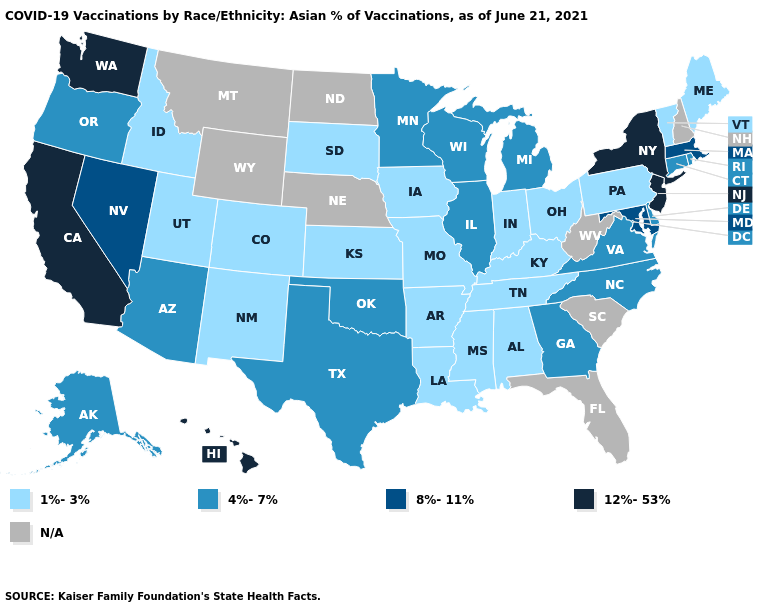Name the states that have a value in the range 4%-7%?
Answer briefly. Alaska, Arizona, Connecticut, Delaware, Georgia, Illinois, Michigan, Minnesota, North Carolina, Oklahoma, Oregon, Rhode Island, Texas, Virginia, Wisconsin. Name the states that have a value in the range 8%-11%?
Give a very brief answer. Maryland, Massachusetts, Nevada. Does Maine have the lowest value in the Northeast?
Quick response, please. Yes. What is the highest value in the Northeast ?
Concise answer only. 12%-53%. What is the lowest value in the West?
Answer briefly. 1%-3%. Name the states that have a value in the range 1%-3%?
Concise answer only. Alabama, Arkansas, Colorado, Idaho, Indiana, Iowa, Kansas, Kentucky, Louisiana, Maine, Mississippi, Missouri, New Mexico, Ohio, Pennsylvania, South Dakota, Tennessee, Utah, Vermont. What is the value of Alabama?
Short answer required. 1%-3%. Which states have the lowest value in the MidWest?
Short answer required. Indiana, Iowa, Kansas, Missouri, Ohio, South Dakota. Name the states that have a value in the range 12%-53%?
Give a very brief answer. California, Hawaii, New Jersey, New York, Washington. Does the first symbol in the legend represent the smallest category?
Concise answer only. Yes. What is the lowest value in the USA?
Give a very brief answer. 1%-3%. Among the states that border Tennessee , does Virginia have the lowest value?
Quick response, please. No. Among the states that border Connecticut , does New York have the highest value?
Keep it brief. Yes. 